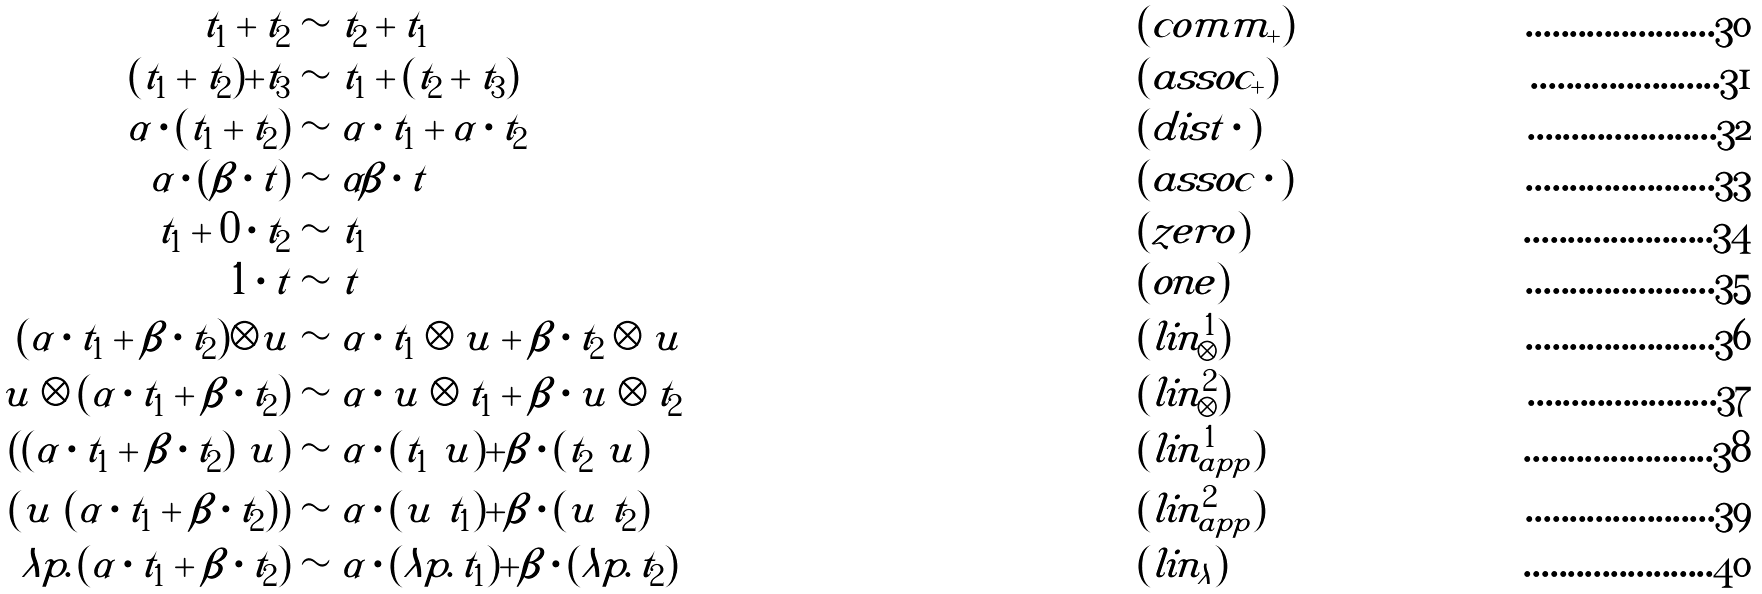<formula> <loc_0><loc_0><loc_500><loc_500>t _ { 1 } + t _ { 2 } & \sim t _ { 2 } + t _ { 1 } & & ( c o m m _ { + } ) \\ ( t _ { 1 } + t _ { 2 } ) + t _ { 3 } & \sim t _ { 1 } + ( t _ { 2 } + t _ { 3 } ) & & ( a s s o c _ { + } ) \\ \alpha \cdot ( t _ { 1 } + t _ { 2 } ) & \sim \alpha \cdot t _ { 1 } + \alpha \cdot t _ { 2 } & & ( d i s t \cdot ) \\ \alpha \cdot ( \beta \cdot t ) & \sim \alpha \beta \cdot t & & ( a s s o c \cdot ) \\ t _ { 1 } + 0 \cdot t _ { 2 } & \sim t _ { 1 } & & ( z e r o ) \\ 1 \cdot t & \sim t & & ( o n e ) \\ ( \alpha \cdot t _ { 1 } + \beta \cdot t _ { 2 } ) \otimes u & \sim \alpha \cdot t _ { 1 } \otimes u + \beta \cdot t _ { 2 } \otimes u & & ( l i n ^ { 1 } _ { \otimes } ) \\ u \otimes ( \alpha \cdot t _ { 1 } + \beta \cdot t _ { 2 } ) & \sim \alpha \cdot u \otimes t _ { 1 } + \beta \cdot u \otimes t _ { 2 } & & ( l i n ^ { 2 } _ { \otimes } ) \\ ( ( \alpha \cdot t _ { 1 } + \beta \cdot t _ { 2 } ) \ u ) & \sim \alpha \cdot ( t _ { 1 } \ u ) + \beta \cdot ( t _ { 2 } \ u ) & & ( l i n ^ { 1 } _ { a p p } ) \\ ( u \ ( \alpha \cdot t _ { 1 } + \beta \cdot t _ { 2 } ) ) & \sim \alpha \cdot ( u \ t _ { 1 } ) + \beta \cdot ( u \ t _ { 2 } ) & & ( l i n ^ { 2 } _ { a p p } ) \\ \lambda p . \, ( \alpha \cdot t _ { 1 } + \beta \cdot t _ { 2 } ) & \sim \alpha \cdot ( \lambda p . \, t _ { 1 } ) + \beta \cdot ( \lambda p . \, t _ { 2 } ) & & ( l i n _ { \lambda } )</formula> 